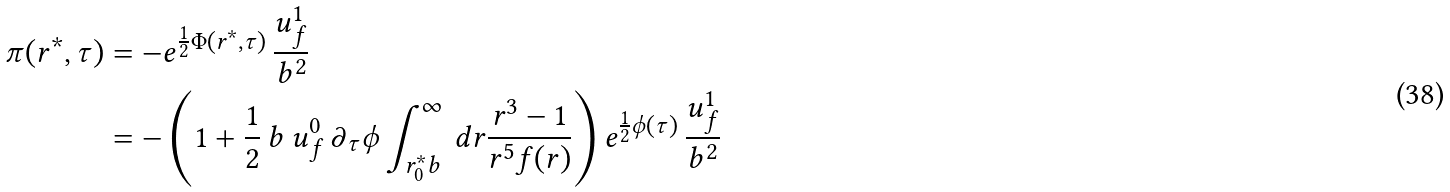<formula> <loc_0><loc_0><loc_500><loc_500>\pi ( r ^ { * } , \tau ) & = - e ^ { \frac { 1 } { 2 } \Phi ( r ^ { * } , \tau ) } \, \frac { u _ { f } ^ { 1 } } { b ^ { 2 } } \\ & = - \left ( 1 + \frac { 1 } { 2 } \, b \, u _ { f } ^ { 0 } \, \partial _ { \tau } { \phi } \int _ { r ^ { * } _ { 0 } b } ^ { \infty } \, d r \frac { r ^ { 3 } - 1 } { r ^ { 5 } f ( r ) } \right ) e ^ { \frac { 1 } { 2 } \phi ( \tau ) } \, \frac { u _ { f } ^ { 1 } } { b ^ { 2 } }</formula> 